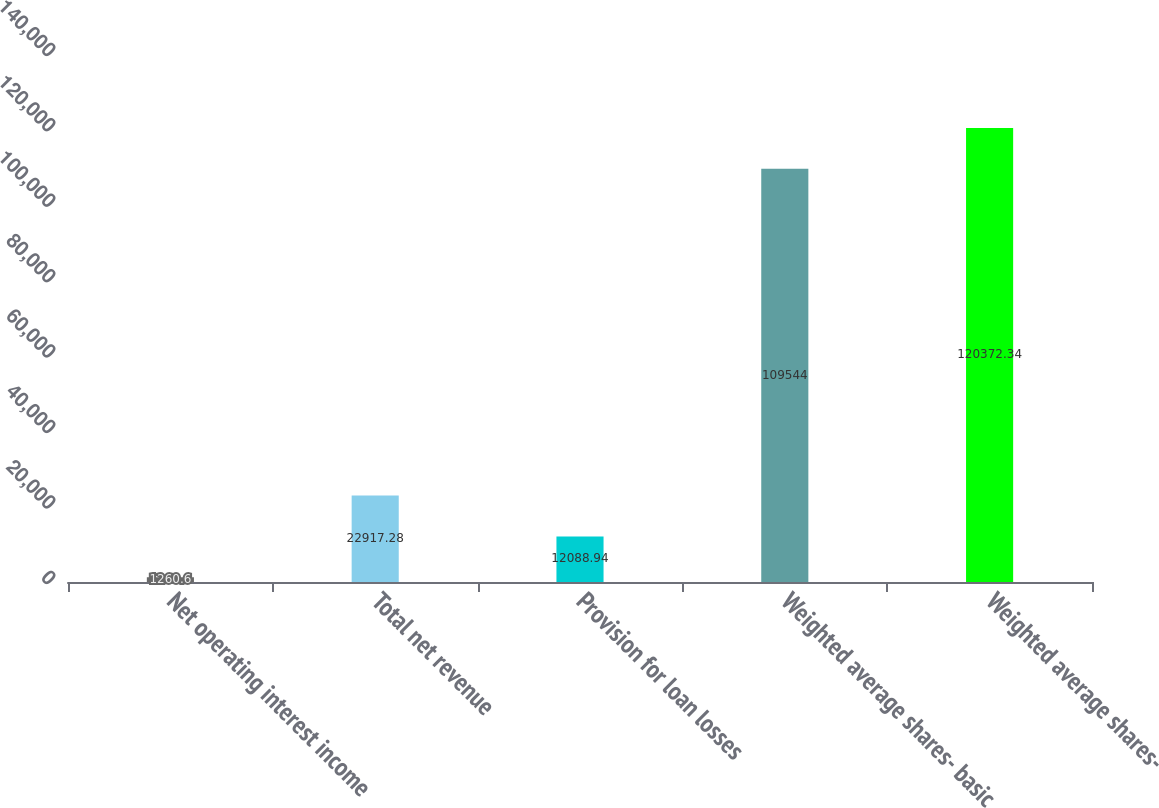<chart> <loc_0><loc_0><loc_500><loc_500><bar_chart><fcel>Net operating interest income<fcel>Total net revenue<fcel>Provision for loan losses<fcel>Weighted average shares- basic<fcel>Weighted average shares-<nl><fcel>1260.6<fcel>22917.3<fcel>12088.9<fcel>109544<fcel>120372<nl></chart> 